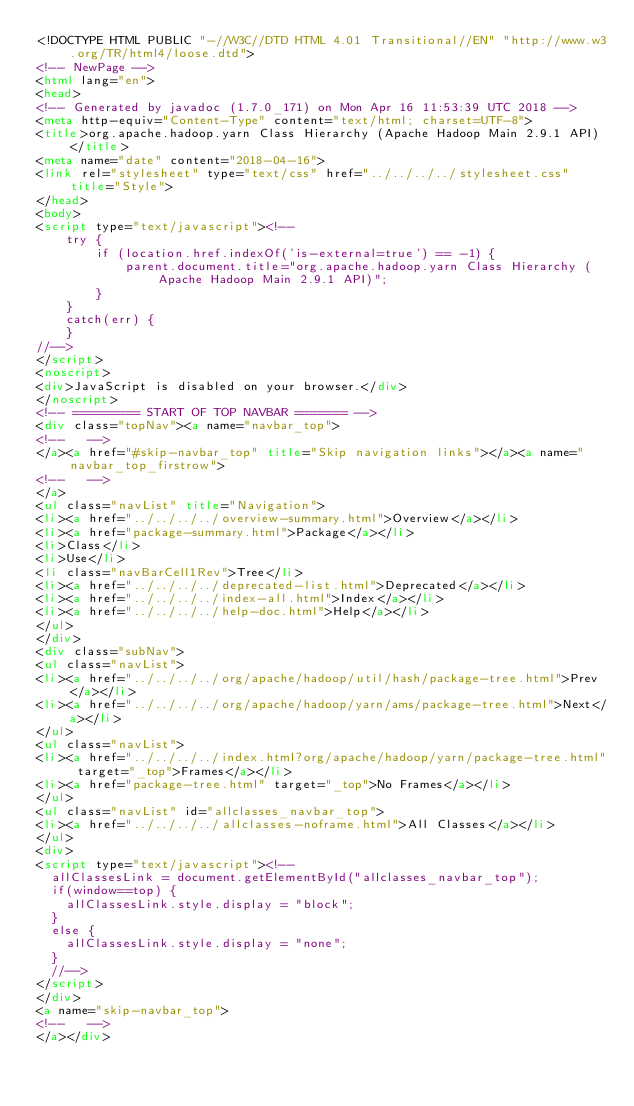<code> <loc_0><loc_0><loc_500><loc_500><_HTML_><!DOCTYPE HTML PUBLIC "-//W3C//DTD HTML 4.01 Transitional//EN" "http://www.w3.org/TR/html4/loose.dtd">
<!-- NewPage -->
<html lang="en">
<head>
<!-- Generated by javadoc (1.7.0_171) on Mon Apr 16 11:53:39 UTC 2018 -->
<meta http-equiv="Content-Type" content="text/html; charset=UTF-8">
<title>org.apache.hadoop.yarn Class Hierarchy (Apache Hadoop Main 2.9.1 API)</title>
<meta name="date" content="2018-04-16">
<link rel="stylesheet" type="text/css" href="../../../../stylesheet.css" title="Style">
</head>
<body>
<script type="text/javascript"><!--
    try {
        if (location.href.indexOf('is-external=true') == -1) {
            parent.document.title="org.apache.hadoop.yarn Class Hierarchy (Apache Hadoop Main 2.9.1 API)";
        }
    }
    catch(err) {
    }
//-->
</script>
<noscript>
<div>JavaScript is disabled on your browser.</div>
</noscript>
<!-- ========= START OF TOP NAVBAR ======= -->
<div class="topNav"><a name="navbar_top">
<!--   -->
</a><a href="#skip-navbar_top" title="Skip navigation links"></a><a name="navbar_top_firstrow">
<!--   -->
</a>
<ul class="navList" title="Navigation">
<li><a href="../../../../overview-summary.html">Overview</a></li>
<li><a href="package-summary.html">Package</a></li>
<li>Class</li>
<li>Use</li>
<li class="navBarCell1Rev">Tree</li>
<li><a href="../../../../deprecated-list.html">Deprecated</a></li>
<li><a href="../../../../index-all.html">Index</a></li>
<li><a href="../../../../help-doc.html">Help</a></li>
</ul>
</div>
<div class="subNav">
<ul class="navList">
<li><a href="../../../../org/apache/hadoop/util/hash/package-tree.html">Prev</a></li>
<li><a href="../../../../org/apache/hadoop/yarn/ams/package-tree.html">Next</a></li>
</ul>
<ul class="navList">
<li><a href="../../../../index.html?org/apache/hadoop/yarn/package-tree.html" target="_top">Frames</a></li>
<li><a href="package-tree.html" target="_top">No Frames</a></li>
</ul>
<ul class="navList" id="allclasses_navbar_top">
<li><a href="../../../../allclasses-noframe.html">All Classes</a></li>
</ul>
<div>
<script type="text/javascript"><!--
  allClassesLink = document.getElementById("allclasses_navbar_top");
  if(window==top) {
    allClassesLink.style.display = "block";
  }
  else {
    allClassesLink.style.display = "none";
  }
  //-->
</script>
</div>
<a name="skip-navbar_top">
<!--   -->
</a></div></code> 